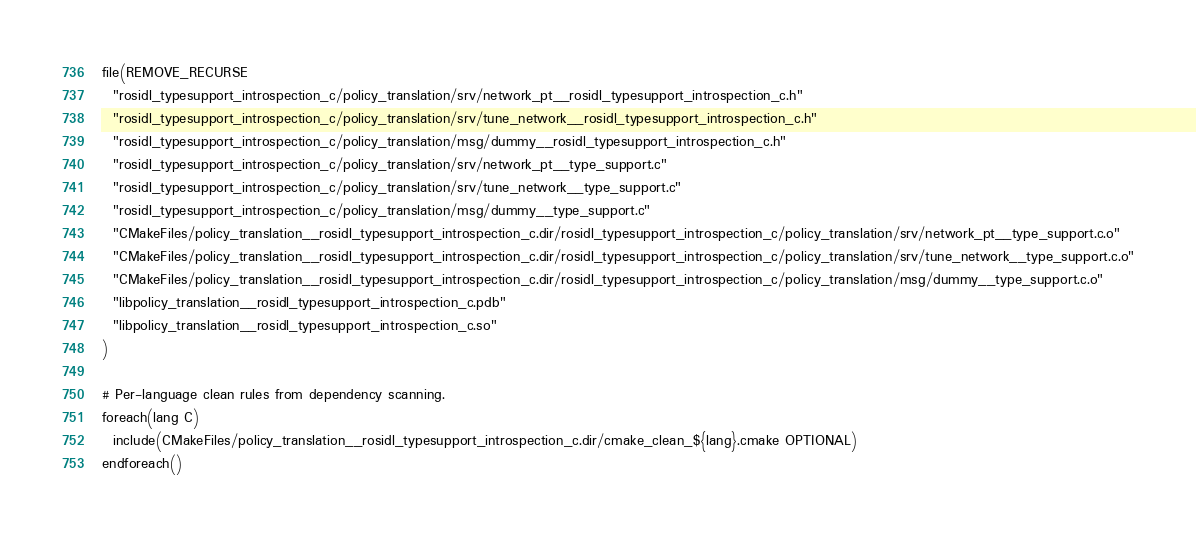Convert code to text. <code><loc_0><loc_0><loc_500><loc_500><_CMake_>file(REMOVE_RECURSE
  "rosidl_typesupport_introspection_c/policy_translation/srv/network_pt__rosidl_typesupport_introspection_c.h"
  "rosidl_typesupport_introspection_c/policy_translation/srv/tune_network__rosidl_typesupport_introspection_c.h"
  "rosidl_typesupport_introspection_c/policy_translation/msg/dummy__rosidl_typesupport_introspection_c.h"
  "rosidl_typesupport_introspection_c/policy_translation/srv/network_pt__type_support.c"
  "rosidl_typesupport_introspection_c/policy_translation/srv/tune_network__type_support.c"
  "rosidl_typesupport_introspection_c/policy_translation/msg/dummy__type_support.c"
  "CMakeFiles/policy_translation__rosidl_typesupport_introspection_c.dir/rosidl_typesupport_introspection_c/policy_translation/srv/network_pt__type_support.c.o"
  "CMakeFiles/policy_translation__rosidl_typesupport_introspection_c.dir/rosidl_typesupport_introspection_c/policy_translation/srv/tune_network__type_support.c.o"
  "CMakeFiles/policy_translation__rosidl_typesupport_introspection_c.dir/rosidl_typesupport_introspection_c/policy_translation/msg/dummy__type_support.c.o"
  "libpolicy_translation__rosidl_typesupport_introspection_c.pdb"
  "libpolicy_translation__rosidl_typesupport_introspection_c.so"
)

# Per-language clean rules from dependency scanning.
foreach(lang C)
  include(CMakeFiles/policy_translation__rosidl_typesupport_introspection_c.dir/cmake_clean_${lang}.cmake OPTIONAL)
endforeach()
</code> 